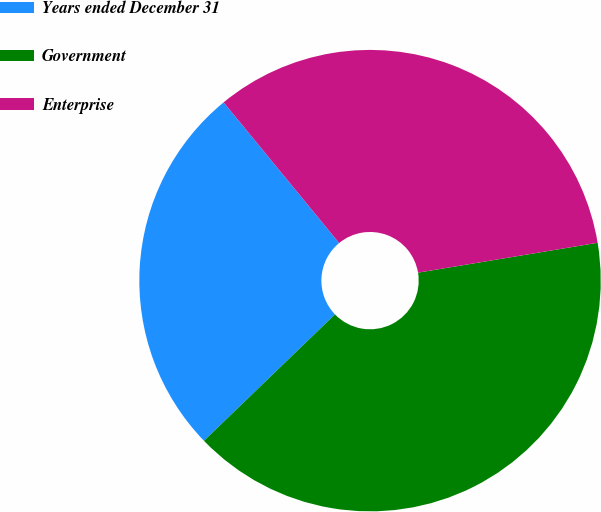<chart> <loc_0><loc_0><loc_500><loc_500><pie_chart><fcel>Years ended December 31<fcel>Government<fcel>Enterprise<nl><fcel>26.27%<fcel>40.41%<fcel>33.32%<nl></chart> 